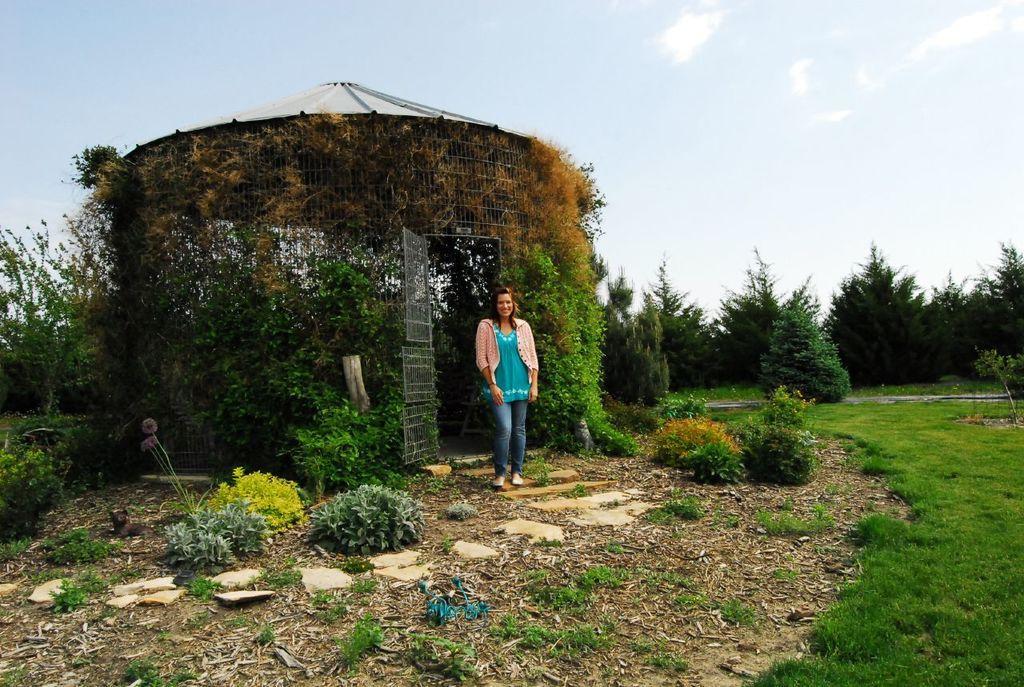Describe this image in one or two sentences. As we can see in the image there are trees, grass, plants, a woman standing over here and on the top there is a sky. 